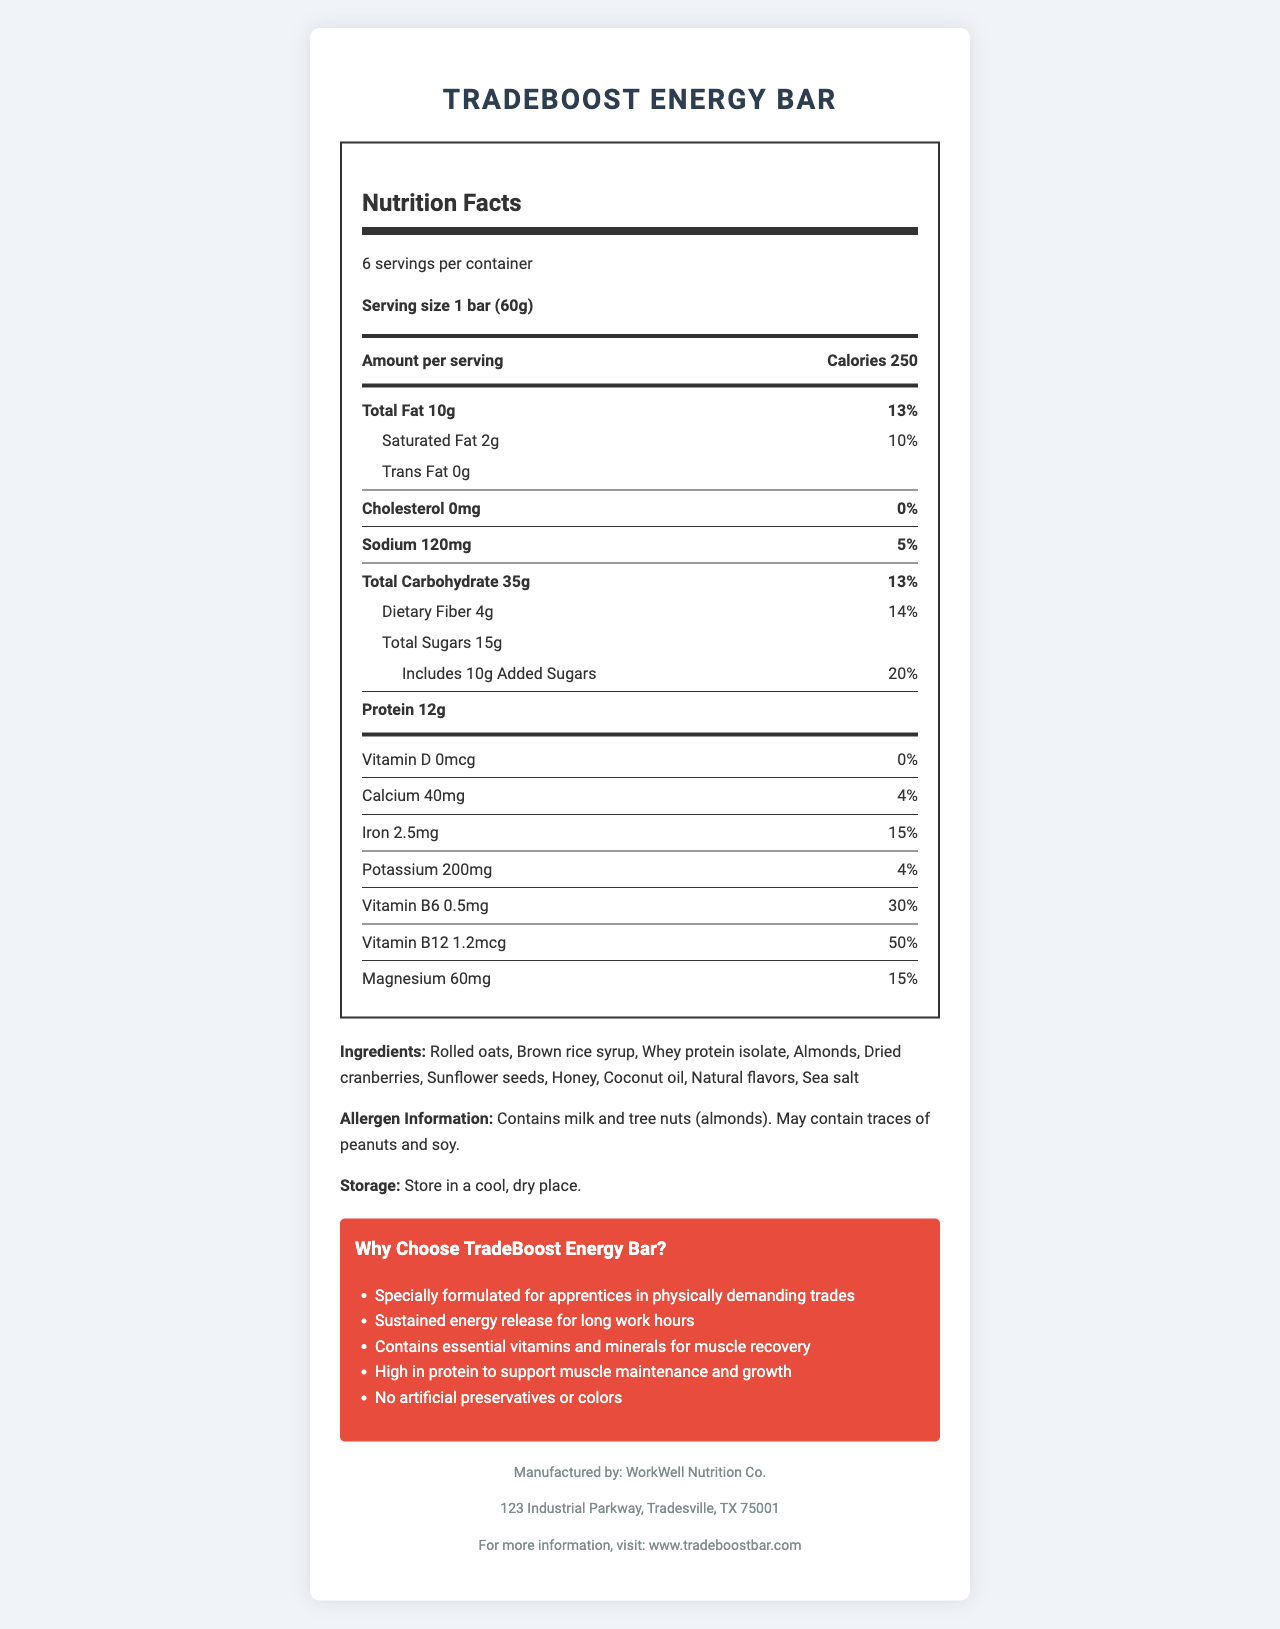what is the serving size of the TradeBoost Energy Bar? The serving size is clearly stated in the document as 1 bar (60g).
Answer: 1 bar (60g) how much protein is in each serving? The protein content per serving is shown as 12g in the nutrition facts section.
Answer: 12g how many grams of dietary fiber does each bar contain? According to the nutrition facts, each bar contains 4g of dietary fiber.
Answer: 4g how many calories are in one bar of the TradeBoost Energy Bar? The number of calories per serving is listed as 250 in the nutrition facts.
Answer: 250 how many servings are there in one container? The document states that there are 6 servings per container.
Answer: 6 what is the total fat content as a percentage of the daily value? A. 10% B. 13% C. 15% D. 20% The document lists the total fat content as 10g, which is 13% of the daily value.
Answer: B which of the following allergens are present in the TradeBoost Energy Bar? A. Peanut B. Gluten C. Tree nuts (almonds) D. Shellfish The allergen information section specifies that the bar contains tree nuts (almonds) and may contain traces of peanuts and soy, but not gluten or shellfish.
Answer: C does the TradeBoost Energy Bar contain any artificial preservatives or colors? The marketing claims section states that the bar contains no artificial preservatives or colors.
Answer: No is the TradeBoost Energy Bar high in protein to support muscle maintenance and growth? One of the marketing claims notes that the bar is high in protein to support muscle maintenance and growth.
Answer: Yes summarize the main features and nutritional aspects of the TradeBoost Energy Bar. This summary covers the product's target audience, nutritional information, key ingredients, and marketing highlights.
Answer: The TradeBoost Energy Bar is specially formulated for apprentices in physically demanding trades, providing sustained energy release and essential vitamins and minerals for muscle recovery. Each bar contains 250 calories, 10g of total fat, 12g of protein, and 35g of carbohydrates, including 4g of dietary fiber and 15g of sugars. Key nutrients include vitamin B6, vitamin B12, and magnesium. The bar contains natural ingredients like rolled oats, whey protein isolate, and dried cranberries, with no artificial preservatives or colors, and it may contain allergens such as milk and tree nuts. The product is manufactured by WorkWell Nutrition Co. and is intended to be a healthy, energy-boosting snack for long work hours. do dried cranberries contribute to the total sugar content? The document lists dried cranberries as an ingredient but does not specify their contribution to the total sugar content.
Answer: Cannot be determined 